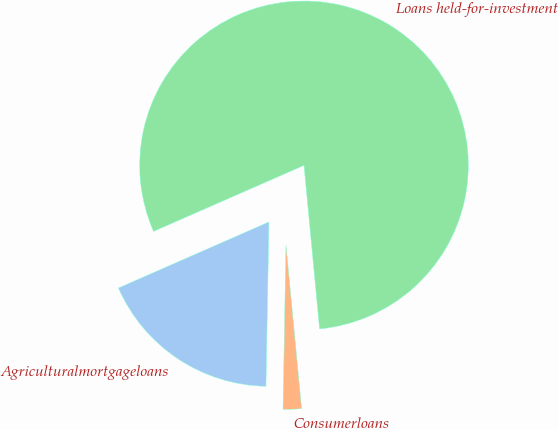Convert chart to OTSL. <chart><loc_0><loc_0><loc_500><loc_500><pie_chart><fcel>Agriculturalmortgageloans<fcel>Consumerloans<fcel>Loans held-for-investment<nl><fcel>18.13%<fcel>1.8%<fcel>80.06%<nl></chart> 